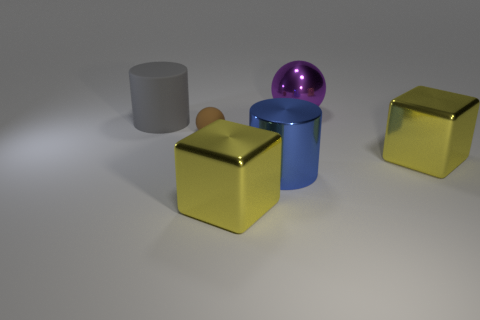Add 4 gray rubber cylinders. How many objects exist? 10 Subtract all cubes. How many objects are left? 4 Subtract all big blue cylinders. Subtract all spheres. How many objects are left? 3 Add 6 brown things. How many brown things are left? 7 Add 1 big purple things. How many big purple things exist? 2 Subtract 0 red balls. How many objects are left? 6 